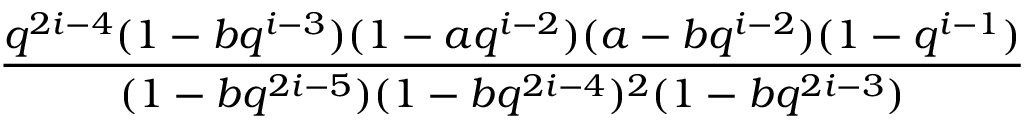<formula> <loc_0><loc_0><loc_500><loc_500>\frac { q ^ { 2 i - 4 } ( 1 - b q ^ { i - 3 } ) ( 1 - a q ^ { i - 2 } ) ( a - b q ^ { i - 2 } ) ( 1 - q ^ { i - 1 } ) } { ( 1 - b q ^ { 2 i - 5 } ) ( 1 - b q ^ { 2 i - 4 } ) ^ { 2 } ( 1 - b q ^ { 2 i - 3 } ) }</formula> 